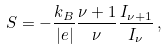Convert formula to latex. <formula><loc_0><loc_0><loc_500><loc_500>S = - \frac { k _ { B } } { | e | } \frac { \nu + 1 } { \nu } \frac { I _ { \nu + 1 } } { I _ { \nu } } \, ,</formula> 